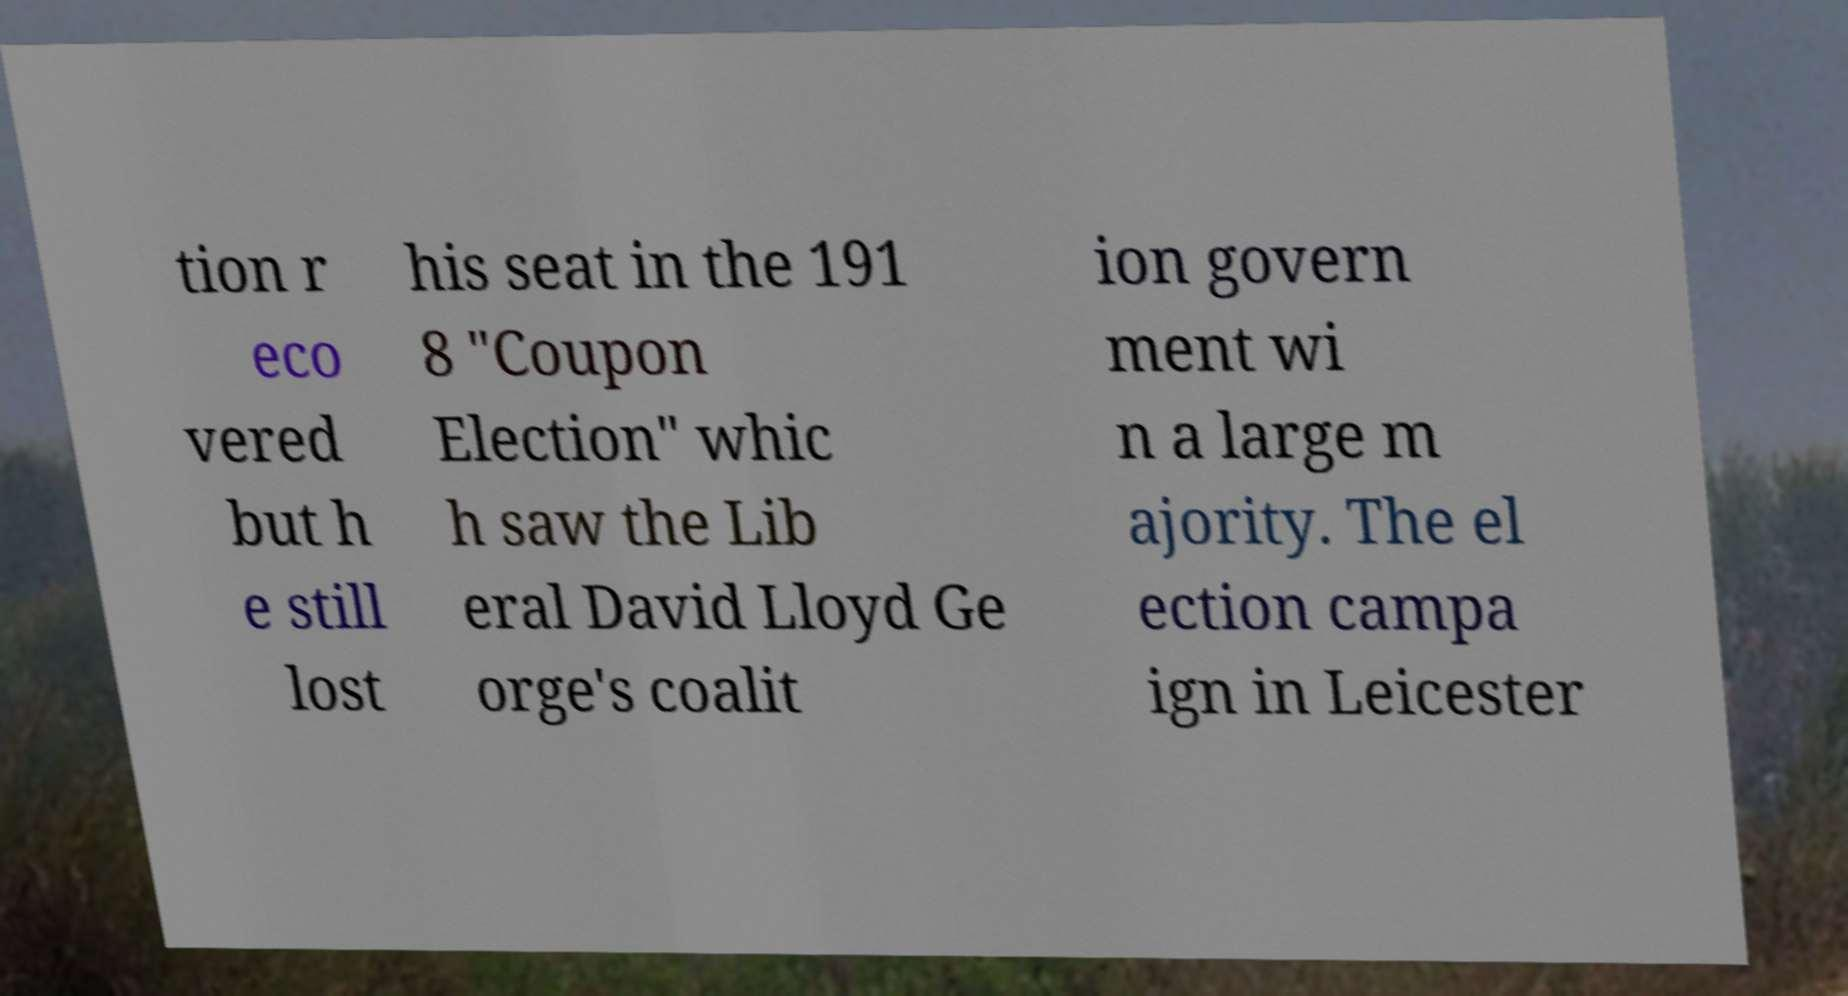Please identify and transcribe the text found in this image. tion r eco vered but h e still lost his seat in the 191 8 "Coupon Election" whic h saw the Lib eral David Lloyd Ge orge's coalit ion govern ment wi n a large m ajority. The el ection campa ign in Leicester 